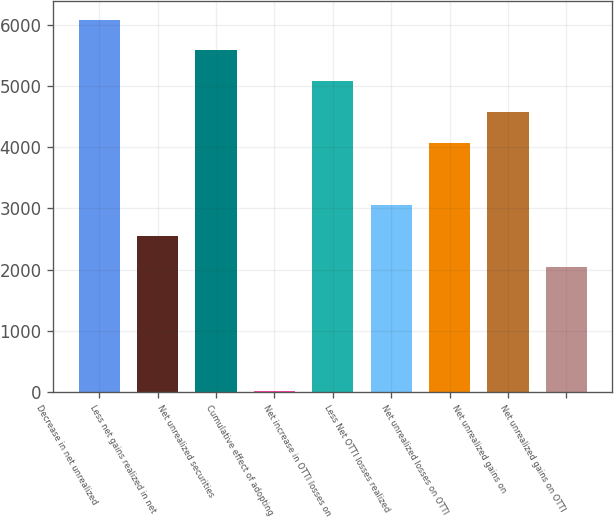Convert chart. <chart><loc_0><loc_0><loc_500><loc_500><bar_chart><fcel>Decrease in net unrealized<fcel>Less net gains realized in net<fcel>Net unrealized securities<fcel>Cumulative effect of adopting<fcel>Net increase in OTTI losses on<fcel>Less Net OTTI losses realized<fcel>Net unrealized losses on OTTI<fcel>Net unrealized gains on<fcel>Net unrealized gains on OTTI<nl><fcel>6086<fcel>2547.5<fcel>5580.5<fcel>20<fcel>5075<fcel>3053<fcel>4064<fcel>4569.5<fcel>2042<nl></chart> 